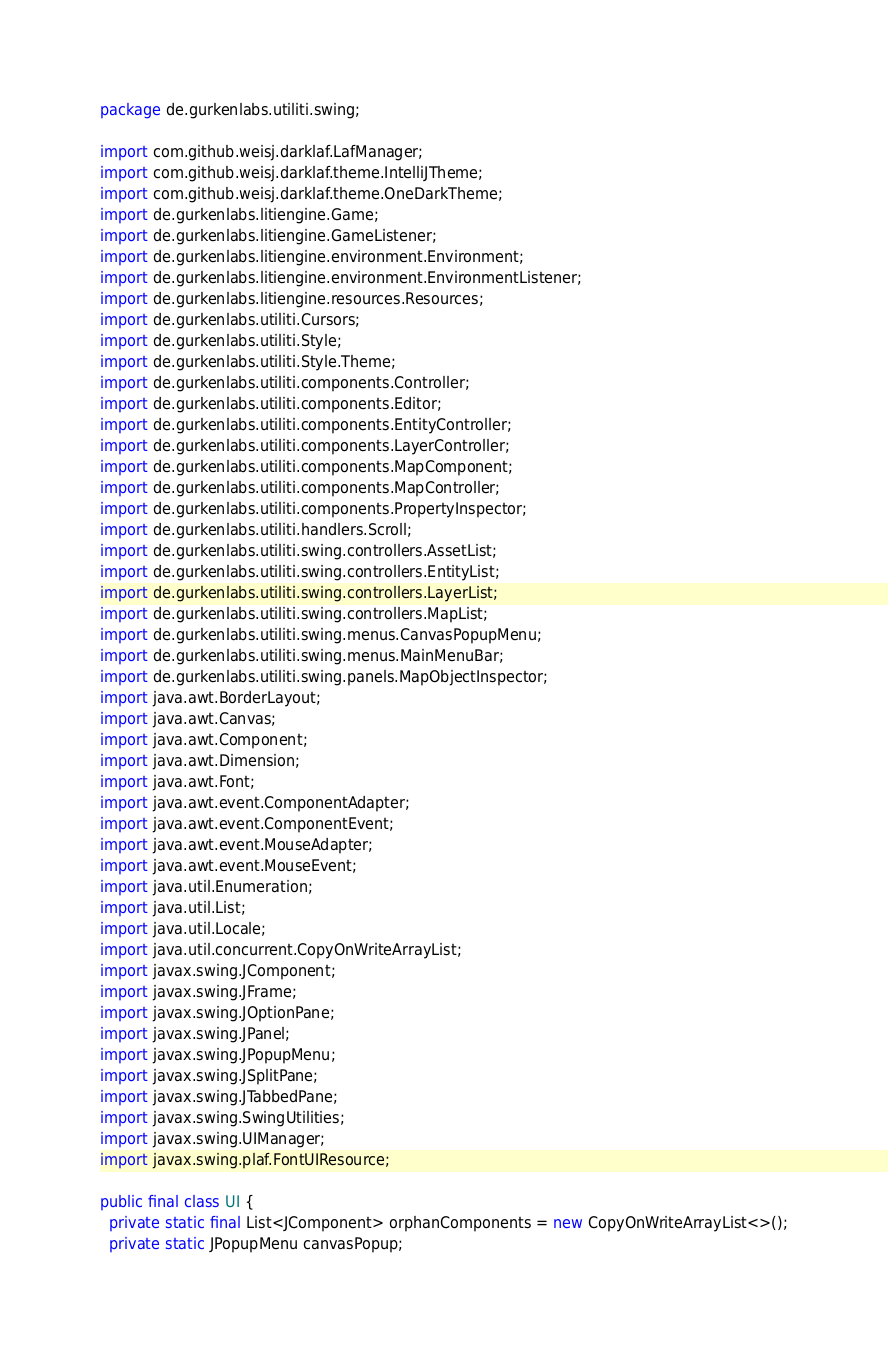Convert code to text. <code><loc_0><loc_0><loc_500><loc_500><_Java_>package de.gurkenlabs.utiliti.swing;

import com.github.weisj.darklaf.LafManager;
import com.github.weisj.darklaf.theme.IntelliJTheme;
import com.github.weisj.darklaf.theme.OneDarkTheme;
import de.gurkenlabs.litiengine.Game;
import de.gurkenlabs.litiengine.GameListener;
import de.gurkenlabs.litiengine.environment.Environment;
import de.gurkenlabs.litiengine.environment.EnvironmentListener;
import de.gurkenlabs.litiengine.resources.Resources;
import de.gurkenlabs.utiliti.Cursors;
import de.gurkenlabs.utiliti.Style;
import de.gurkenlabs.utiliti.Style.Theme;
import de.gurkenlabs.utiliti.components.Controller;
import de.gurkenlabs.utiliti.components.Editor;
import de.gurkenlabs.utiliti.components.EntityController;
import de.gurkenlabs.utiliti.components.LayerController;
import de.gurkenlabs.utiliti.components.MapComponent;
import de.gurkenlabs.utiliti.components.MapController;
import de.gurkenlabs.utiliti.components.PropertyInspector;
import de.gurkenlabs.utiliti.handlers.Scroll;
import de.gurkenlabs.utiliti.swing.controllers.AssetList;
import de.gurkenlabs.utiliti.swing.controllers.EntityList;
import de.gurkenlabs.utiliti.swing.controllers.LayerList;
import de.gurkenlabs.utiliti.swing.controllers.MapList;
import de.gurkenlabs.utiliti.swing.menus.CanvasPopupMenu;
import de.gurkenlabs.utiliti.swing.menus.MainMenuBar;
import de.gurkenlabs.utiliti.swing.panels.MapObjectInspector;
import java.awt.BorderLayout;
import java.awt.Canvas;
import java.awt.Component;
import java.awt.Dimension;
import java.awt.Font;
import java.awt.event.ComponentAdapter;
import java.awt.event.ComponentEvent;
import java.awt.event.MouseAdapter;
import java.awt.event.MouseEvent;
import java.util.Enumeration;
import java.util.List;
import java.util.Locale;
import java.util.concurrent.CopyOnWriteArrayList;
import javax.swing.JComponent;
import javax.swing.JFrame;
import javax.swing.JOptionPane;
import javax.swing.JPanel;
import javax.swing.JPopupMenu;
import javax.swing.JSplitPane;
import javax.swing.JTabbedPane;
import javax.swing.SwingUtilities;
import javax.swing.UIManager;
import javax.swing.plaf.FontUIResource;

public final class UI {
  private static final List<JComponent> orphanComponents = new CopyOnWriteArrayList<>();
  private static JPopupMenu canvasPopup;</code> 